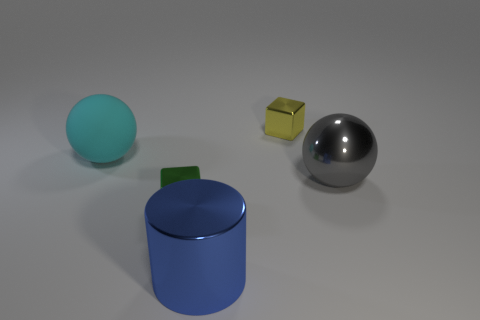Add 2 cyan matte spheres. How many objects exist? 7 Subtract all cylinders. How many objects are left? 4 Subtract all blue cylinders. Subtract all green shiny cubes. How many objects are left? 3 Add 4 gray balls. How many gray balls are left? 5 Add 4 large cylinders. How many large cylinders exist? 5 Subtract 0 red cylinders. How many objects are left? 5 